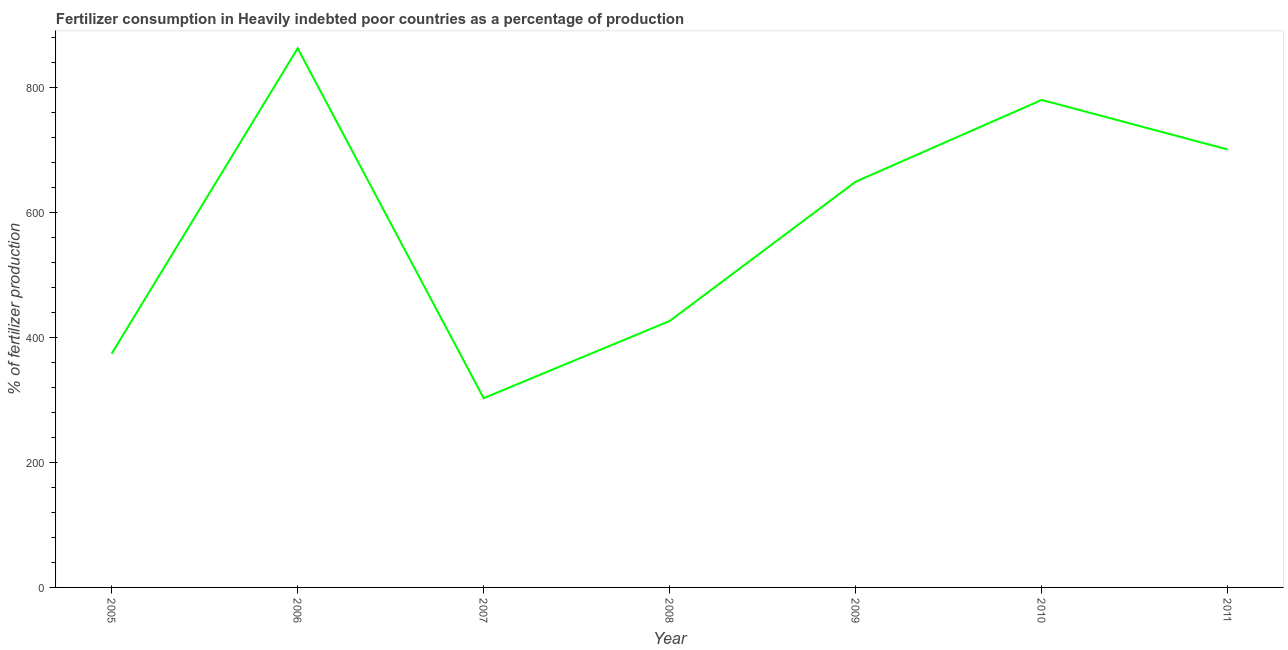What is the amount of fertilizer consumption in 2011?
Your answer should be compact. 700.34. Across all years, what is the maximum amount of fertilizer consumption?
Your answer should be very brief. 862.17. Across all years, what is the minimum amount of fertilizer consumption?
Keep it short and to the point. 302.7. What is the sum of the amount of fertilizer consumption?
Your answer should be compact. 4093.64. What is the difference between the amount of fertilizer consumption in 2005 and 2010?
Keep it short and to the point. -405.78. What is the average amount of fertilizer consumption per year?
Your answer should be very brief. 584.81. What is the median amount of fertilizer consumption?
Give a very brief answer. 648.85. Do a majority of the years between 2005 and 2007 (inclusive) have amount of fertilizer consumption greater than 680 %?
Make the answer very short. No. What is the ratio of the amount of fertilizer consumption in 2005 to that in 2006?
Provide a succinct answer. 0.43. Is the amount of fertilizer consumption in 2009 less than that in 2010?
Provide a short and direct response. Yes. Is the difference between the amount of fertilizer consumption in 2006 and 2009 greater than the difference between any two years?
Your answer should be very brief. No. What is the difference between the highest and the second highest amount of fertilizer consumption?
Offer a terse response. 82.54. Is the sum of the amount of fertilizer consumption in 2010 and 2011 greater than the maximum amount of fertilizer consumption across all years?
Give a very brief answer. Yes. What is the difference between the highest and the lowest amount of fertilizer consumption?
Ensure brevity in your answer.  559.47. Does the amount of fertilizer consumption monotonically increase over the years?
Make the answer very short. No. How many years are there in the graph?
Make the answer very short. 7. What is the difference between two consecutive major ticks on the Y-axis?
Ensure brevity in your answer.  200. Does the graph contain any zero values?
Give a very brief answer. No. Does the graph contain grids?
Offer a very short reply. No. What is the title of the graph?
Provide a succinct answer. Fertilizer consumption in Heavily indebted poor countries as a percentage of production. What is the label or title of the Y-axis?
Provide a succinct answer. % of fertilizer production. What is the % of fertilizer production in 2005?
Ensure brevity in your answer.  373.84. What is the % of fertilizer production of 2006?
Ensure brevity in your answer.  862.17. What is the % of fertilizer production in 2007?
Provide a short and direct response. 302.7. What is the % of fertilizer production of 2008?
Offer a very short reply. 426.11. What is the % of fertilizer production of 2009?
Offer a terse response. 648.85. What is the % of fertilizer production in 2010?
Your answer should be compact. 779.62. What is the % of fertilizer production in 2011?
Give a very brief answer. 700.34. What is the difference between the % of fertilizer production in 2005 and 2006?
Ensure brevity in your answer.  -488.32. What is the difference between the % of fertilizer production in 2005 and 2007?
Offer a very short reply. 71.14. What is the difference between the % of fertilizer production in 2005 and 2008?
Your answer should be very brief. -52.27. What is the difference between the % of fertilizer production in 2005 and 2009?
Offer a very short reply. -275.01. What is the difference between the % of fertilizer production in 2005 and 2010?
Provide a succinct answer. -405.78. What is the difference between the % of fertilizer production in 2005 and 2011?
Ensure brevity in your answer.  -326.5. What is the difference between the % of fertilizer production in 2006 and 2007?
Give a very brief answer. 559.47. What is the difference between the % of fertilizer production in 2006 and 2008?
Provide a succinct answer. 436.06. What is the difference between the % of fertilizer production in 2006 and 2009?
Your response must be concise. 213.31. What is the difference between the % of fertilizer production in 2006 and 2010?
Ensure brevity in your answer.  82.54. What is the difference between the % of fertilizer production in 2006 and 2011?
Offer a very short reply. 161.82. What is the difference between the % of fertilizer production in 2007 and 2008?
Your answer should be very brief. -123.41. What is the difference between the % of fertilizer production in 2007 and 2009?
Keep it short and to the point. -346.16. What is the difference between the % of fertilizer production in 2007 and 2010?
Keep it short and to the point. -476.93. What is the difference between the % of fertilizer production in 2007 and 2011?
Keep it short and to the point. -397.65. What is the difference between the % of fertilizer production in 2008 and 2009?
Provide a short and direct response. -222.75. What is the difference between the % of fertilizer production in 2008 and 2010?
Provide a short and direct response. -353.51. What is the difference between the % of fertilizer production in 2008 and 2011?
Your answer should be compact. -274.24. What is the difference between the % of fertilizer production in 2009 and 2010?
Offer a very short reply. -130.77. What is the difference between the % of fertilizer production in 2009 and 2011?
Your answer should be very brief. -51.49. What is the difference between the % of fertilizer production in 2010 and 2011?
Give a very brief answer. 79.28. What is the ratio of the % of fertilizer production in 2005 to that in 2006?
Offer a very short reply. 0.43. What is the ratio of the % of fertilizer production in 2005 to that in 2007?
Your response must be concise. 1.24. What is the ratio of the % of fertilizer production in 2005 to that in 2008?
Provide a short and direct response. 0.88. What is the ratio of the % of fertilizer production in 2005 to that in 2009?
Keep it short and to the point. 0.58. What is the ratio of the % of fertilizer production in 2005 to that in 2010?
Provide a short and direct response. 0.48. What is the ratio of the % of fertilizer production in 2005 to that in 2011?
Ensure brevity in your answer.  0.53. What is the ratio of the % of fertilizer production in 2006 to that in 2007?
Make the answer very short. 2.85. What is the ratio of the % of fertilizer production in 2006 to that in 2008?
Provide a short and direct response. 2.02. What is the ratio of the % of fertilizer production in 2006 to that in 2009?
Provide a succinct answer. 1.33. What is the ratio of the % of fertilizer production in 2006 to that in 2010?
Make the answer very short. 1.11. What is the ratio of the % of fertilizer production in 2006 to that in 2011?
Provide a succinct answer. 1.23. What is the ratio of the % of fertilizer production in 2007 to that in 2008?
Offer a terse response. 0.71. What is the ratio of the % of fertilizer production in 2007 to that in 2009?
Make the answer very short. 0.47. What is the ratio of the % of fertilizer production in 2007 to that in 2010?
Give a very brief answer. 0.39. What is the ratio of the % of fertilizer production in 2007 to that in 2011?
Provide a short and direct response. 0.43. What is the ratio of the % of fertilizer production in 2008 to that in 2009?
Make the answer very short. 0.66. What is the ratio of the % of fertilizer production in 2008 to that in 2010?
Make the answer very short. 0.55. What is the ratio of the % of fertilizer production in 2008 to that in 2011?
Keep it short and to the point. 0.61. What is the ratio of the % of fertilizer production in 2009 to that in 2010?
Provide a succinct answer. 0.83. What is the ratio of the % of fertilizer production in 2009 to that in 2011?
Provide a short and direct response. 0.93. What is the ratio of the % of fertilizer production in 2010 to that in 2011?
Offer a very short reply. 1.11. 